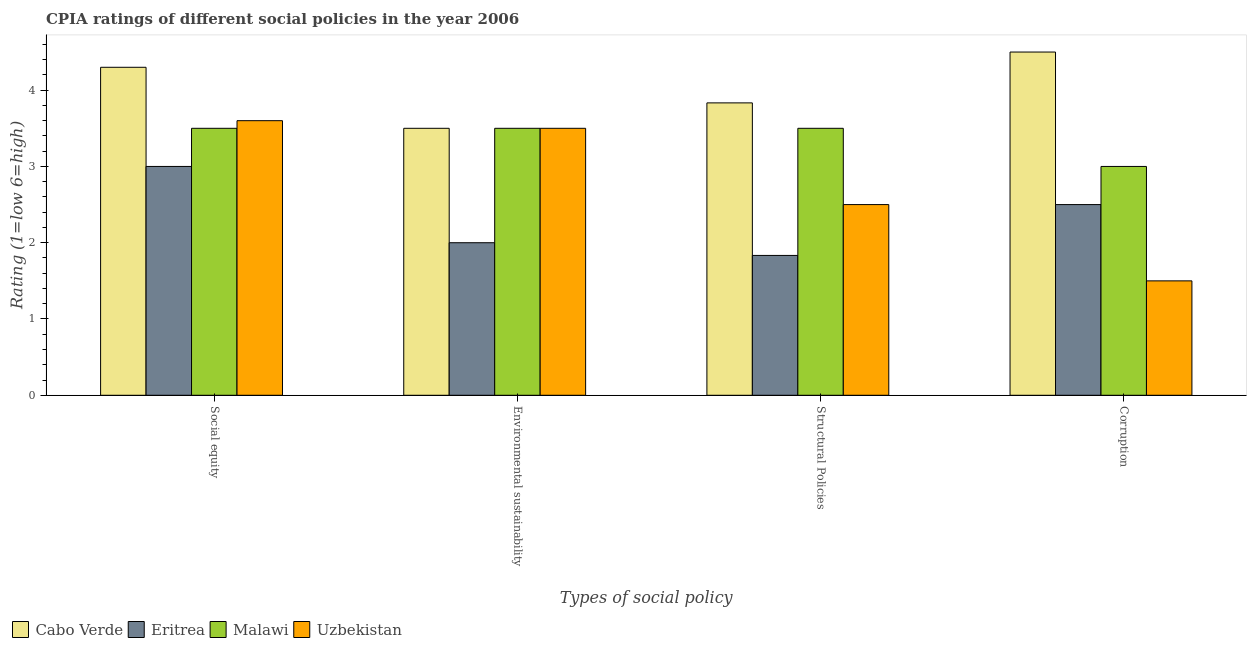Are the number of bars per tick equal to the number of legend labels?
Offer a terse response. Yes. Are the number of bars on each tick of the X-axis equal?
Keep it short and to the point. Yes. How many bars are there on the 2nd tick from the right?
Your answer should be very brief. 4. What is the label of the 3rd group of bars from the left?
Provide a succinct answer. Structural Policies. Across all countries, what is the maximum cpia rating of social equity?
Give a very brief answer. 4.3. In which country was the cpia rating of corruption maximum?
Give a very brief answer. Cabo Verde. In which country was the cpia rating of corruption minimum?
Provide a succinct answer. Uzbekistan. What is the total cpia rating of social equity in the graph?
Keep it short and to the point. 14.4. What is the average cpia rating of social equity per country?
Your answer should be very brief. 3.6. What is the difference between the cpia rating of structural policies and cpia rating of environmental sustainability in Cabo Verde?
Your response must be concise. 0.33. Is the difference between the cpia rating of environmental sustainability in Eritrea and Uzbekistan greater than the difference between the cpia rating of corruption in Eritrea and Uzbekistan?
Offer a terse response. No. What is the difference between the highest and the second highest cpia rating of structural policies?
Your answer should be compact. 0.33. What is the difference between the highest and the lowest cpia rating of corruption?
Keep it short and to the point. 3. In how many countries, is the cpia rating of social equity greater than the average cpia rating of social equity taken over all countries?
Your answer should be very brief. 1. Is the sum of the cpia rating of corruption in Uzbekistan and Cabo Verde greater than the maximum cpia rating of social equity across all countries?
Your answer should be compact. Yes. What does the 1st bar from the left in Corruption represents?
Offer a terse response. Cabo Verde. What does the 4th bar from the right in Environmental sustainability represents?
Your answer should be very brief. Cabo Verde. How many countries are there in the graph?
Ensure brevity in your answer.  4. What is the difference between two consecutive major ticks on the Y-axis?
Provide a short and direct response. 1. Are the values on the major ticks of Y-axis written in scientific E-notation?
Keep it short and to the point. No. Does the graph contain any zero values?
Provide a succinct answer. No. How many legend labels are there?
Make the answer very short. 4. How are the legend labels stacked?
Give a very brief answer. Horizontal. What is the title of the graph?
Your answer should be compact. CPIA ratings of different social policies in the year 2006. Does "Iran" appear as one of the legend labels in the graph?
Offer a very short reply. No. What is the label or title of the X-axis?
Make the answer very short. Types of social policy. What is the label or title of the Y-axis?
Give a very brief answer. Rating (1=low 6=high). What is the Rating (1=low 6=high) in Malawi in Social equity?
Your response must be concise. 3.5. What is the Rating (1=low 6=high) in Cabo Verde in Environmental sustainability?
Your answer should be very brief. 3.5. What is the Rating (1=low 6=high) of Malawi in Environmental sustainability?
Your response must be concise. 3.5. What is the Rating (1=low 6=high) in Uzbekistan in Environmental sustainability?
Provide a short and direct response. 3.5. What is the Rating (1=low 6=high) of Cabo Verde in Structural Policies?
Make the answer very short. 3.83. What is the Rating (1=low 6=high) of Eritrea in Structural Policies?
Provide a short and direct response. 1.83. What is the Rating (1=low 6=high) of Uzbekistan in Structural Policies?
Your answer should be compact. 2.5. What is the Rating (1=low 6=high) in Eritrea in Corruption?
Your answer should be very brief. 2.5. Across all Types of social policy, what is the maximum Rating (1=low 6=high) in Cabo Verde?
Offer a very short reply. 4.5. Across all Types of social policy, what is the maximum Rating (1=low 6=high) of Malawi?
Your response must be concise. 3.5. Across all Types of social policy, what is the minimum Rating (1=low 6=high) in Cabo Verde?
Give a very brief answer. 3.5. Across all Types of social policy, what is the minimum Rating (1=low 6=high) in Eritrea?
Your answer should be very brief. 1.83. What is the total Rating (1=low 6=high) of Cabo Verde in the graph?
Your response must be concise. 16.13. What is the total Rating (1=low 6=high) of Eritrea in the graph?
Make the answer very short. 9.33. What is the difference between the Rating (1=low 6=high) in Eritrea in Social equity and that in Environmental sustainability?
Give a very brief answer. 1. What is the difference between the Rating (1=low 6=high) of Uzbekistan in Social equity and that in Environmental sustainability?
Your response must be concise. 0.1. What is the difference between the Rating (1=low 6=high) of Cabo Verde in Social equity and that in Structural Policies?
Your response must be concise. 0.47. What is the difference between the Rating (1=low 6=high) in Eritrea in Social equity and that in Structural Policies?
Provide a succinct answer. 1.17. What is the difference between the Rating (1=low 6=high) in Malawi in Social equity and that in Structural Policies?
Ensure brevity in your answer.  0. What is the difference between the Rating (1=low 6=high) in Uzbekistan in Social equity and that in Structural Policies?
Provide a succinct answer. 1.1. What is the difference between the Rating (1=low 6=high) in Eritrea in Social equity and that in Corruption?
Give a very brief answer. 0.5. What is the difference between the Rating (1=low 6=high) in Uzbekistan in Social equity and that in Corruption?
Make the answer very short. 2.1. What is the difference between the Rating (1=low 6=high) of Cabo Verde in Environmental sustainability and that in Structural Policies?
Offer a terse response. -0.33. What is the difference between the Rating (1=low 6=high) in Malawi in Environmental sustainability and that in Structural Policies?
Keep it short and to the point. 0. What is the difference between the Rating (1=low 6=high) of Cabo Verde in Environmental sustainability and that in Corruption?
Your answer should be compact. -1. What is the difference between the Rating (1=low 6=high) in Eritrea in Environmental sustainability and that in Corruption?
Ensure brevity in your answer.  -0.5. What is the difference between the Rating (1=low 6=high) of Malawi in Environmental sustainability and that in Corruption?
Your answer should be compact. 0.5. What is the difference between the Rating (1=low 6=high) of Cabo Verde in Social equity and the Rating (1=low 6=high) of Malawi in Environmental sustainability?
Your answer should be very brief. 0.8. What is the difference between the Rating (1=low 6=high) in Cabo Verde in Social equity and the Rating (1=low 6=high) in Uzbekistan in Environmental sustainability?
Give a very brief answer. 0.8. What is the difference between the Rating (1=low 6=high) of Eritrea in Social equity and the Rating (1=low 6=high) of Malawi in Environmental sustainability?
Ensure brevity in your answer.  -0.5. What is the difference between the Rating (1=low 6=high) in Malawi in Social equity and the Rating (1=low 6=high) in Uzbekistan in Environmental sustainability?
Offer a very short reply. 0. What is the difference between the Rating (1=low 6=high) of Cabo Verde in Social equity and the Rating (1=low 6=high) of Eritrea in Structural Policies?
Keep it short and to the point. 2.47. What is the difference between the Rating (1=low 6=high) of Cabo Verde in Social equity and the Rating (1=low 6=high) of Malawi in Structural Policies?
Offer a very short reply. 0.8. What is the difference between the Rating (1=low 6=high) of Cabo Verde in Social equity and the Rating (1=low 6=high) of Uzbekistan in Structural Policies?
Keep it short and to the point. 1.8. What is the difference between the Rating (1=low 6=high) of Malawi in Social equity and the Rating (1=low 6=high) of Uzbekistan in Structural Policies?
Your response must be concise. 1. What is the difference between the Rating (1=low 6=high) in Cabo Verde in Social equity and the Rating (1=low 6=high) in Eritrea in Corruption?
Provide a succinct answer. 1.8. What is the difference between the Rating (1=low 6=high) in Cabo Verde in Social equity and the Rating (1=low 6=high) in Malawi in Corruption?
Offer a very short reply. 1.3. What is the difference between the Rating (1=low 6=high) in Cabo Verde in Social equity and the Rating (1=low 6=high) in Uzbekistan in Corruption?
Keep it short and to the point. 2.8. What is the difference between the Rating (1=low 6=high) of Eritrea in Social equity and the Rating (1=low 6=high) of Uzbekistan in Corruption?
Offer a very short reply. 1.5. What is the difference between the Rating (1=low 6=high) of Cabo Verde in Environmental sustainability and the Rating (1=low 6=high) of Eritrea in Structural Policies?
Make the answer very short. 1.67. What is the difference between the Rating (1=low 6=high) in Cabo Verde in Environmental sustainability and the Rating (1=low 6=high) in Uzbekistan in Structural Policies?
Offer a very short reply. 1. What is the difference between the Rating (1=low 6=high) of Eritrea in Environmental sustainability and the Rating (1=low 6=high) of Malawi in Structural Policies?
Make the answer very short. -1.5. What is the difference between the Rating (1=low 6=high) in Eritrea in Environmental sustainability and the Rating (1=low 6=high) in Uzbekistan in Structural Policies?
Offer a very short reply. -0.5. What is the difference between the Rating (1=low 6=high) in Malawi in Environmental sustainability and the Rating (1=low 6=high) in Uzbekistan in Structural Policies?
Your answer should be compact. 1. What is the difference between the Rating (1=low 6=high) in Cabo Verde in Environmental sustainability and the Rating (1=low 6=high) in Eritrea in Corruption?
Make the answer very short. 1. What is the difference between the Rating (1=low 6=high) in Cabo Verde in Environmental sustainability and the Rating (1=low 6=high) in Uzbekistan in Corruption?
Your answer should be compact. 2. What is the difference between the Rating (1=low 6=high) of Eritrea in Environmental sustainability and the Rating (1=low 6=high) of Uzbekistan in Corruption?
Your answer should be very brief. 0.5. What is the difference between the Rating (1=low 6=high) in Cabo Verde in Structural Policies and the Rating (1=low 6=high) in Eritrea in Corruption?
Offer a very short reply. 1.33. What is the difference between the Rating (1=low 6=high) in Cabo Verde in Structural Policies and the Rating (1=low 6=high) in Malawi in Corruption?
Ensure brevity in your answer.  0.83. What is the difference between the Rating (1=low 6=high) of Cabo Verde in Structural Policies and the Rating (1=low 6=high) of Uzbekistan in Corruption?
Provide a short and direct response. 2.33. What is the difference between the Rating (1=low 6=high) in Eritrea in Structural Policies and the Rating (1=low 6=high) in Malawi in Corruption?
Your answer should be compact. -1.17. What is the difference between the Rating (1=low 6=high) in Eritrea in Structural Policies and the Rating (1=low 6=high) in Uzbekistan in Corruption?
Provide a short and direct response. 0.33. What is the average Rating (1=low 6=high) in Cabo Verde per Types of social policy?
Your answer should be compact. 4.03. What is the average Rating (1=low 6=high) in Eritrea per Types of social policy?
Ensure brevity in your answer.  2.33. What is the average Rating (1=low 6=high) of Malawi per Types of social policy?
Your response must be concise. 3.38. What is the average Rating (1=low 6=high) of Uzbekistan per Types of social policy?
Your answer should be compact. 2.77. What is the difference between the Rating (1=low 6=high) in Cabo Verde and Rating (1=low 6=high) in Eritrea in Social equity?
Provide a short and direct response. 1.3. What is the difference between the Rating (1=low 6=high) in Cabo Verde and Rating (1=low 6=high) in Malawi in Social equity?
Your response must be concise. 0.8. What is the difference between the Rating (1=low 6=high) of Cabo Verde and Rating (1=low 6=high) of Uzbekistan in Social equity?
Your answer should be compact. 0.7. What is the difference between the Rating (1=low 6=high) of Eritrea and Rating (1=low 6=high) of Uzbekistan in Social equity?
Your answer should be compact. -0.6. What is the difference between the Rating (1=low 6=high) of Malawi and Rating (1=low 6=high) of Uzbekistan in Social equity?
Offer a very short reply. -0.1. What is the difference between the Rating (1=low 6=high) of Cabo Verde and Rating (1=low 6=high) of Uzbekistan in Environmental sustainability?
Provide a succinct answer. 0. What is the difference between the Rating (1=low 6=high) in Eritrea and Rating (1=low 6=high) in Malawi in Environmental sustainability?
Make the answer very short. -1.5. What is the difference between the Rating (1=low 6=high) in Eritrea and Rating (1=low 6=high) in Uzbekistan in Environmental sustainability?
Ensure brevity in your answer.  -1.5. What is the difference between the Rating (1=low 6=high) of Malawi and Rating (1=low 6=high) of Uzbekistan in Environmental sustainability?
Provide a succinct answer. 0. What is the difference between the Rating (1=low 6=high) of Cabo Verde and Rating (1=low 6=high) of Eritrea in Structural Policies?
Provide a short and direct response. 2. What is the difference between the Rating (1=low 6=high) in Cabo Verde and Rating (1=low 6=high) in Uzbekistan in Structural Policies?
Ensure brevity in your answer.  1.33. What is the difference between the Rating (1=low 6=high) of Eritrea and Rating (1=low 6=high) of Malawi in Structural Policies?
Give a very brief answer. -1.67. What is the difference between the Rating (1=low 6=high) of Eritrea and Rating (1=low 6=high) of Uzbekistan in Structural Policies?
Keep it short and to the point. -0.67. What is the difference between the Rating (1=low 6=high) of Malawi and Rating (1=low 6=high) of Uzbekistan in Structural Policies?
Give a very brief answer. 1. What is the difference between the Rating (1=low 6=high) in Cabo Verde and Rating (1=low 6=high) in Malawi in Corruption?
Your answer should be compact. 1.5. What is the difference between the Rating (1=low 6=high) in Cabo Verde and Rating (1=low 6=high) in Uzbekistan in Corruption?
Give a very brief answer. 3. What is the ratio of the Rating (1=low 6=high) of Cabo Verde in Social equity to that in Environmental sustainability?
Provide a succinct answer. 1.23. What is the ratio of the Rating (1=low 6=high) of Uzbekistan in Social equity to that in Environmental sustainability?
Offer a very short reply. 1.03. What is the ratio of the Rating (1=low 6=high) in Cabo Verde in Social equity to that in Structural Policies?
Provide a short and direct response. 1.12. What is the ratio of the Rating (1=low 6=high) of Eritrea in Social equity to that in Structural Policies?
Ensure brevity in your answer.  1.64. What is the ratio of the Rating (1=low 6=high) in Malawi in Social equity to that in Structural Policies?
Your response must be concise. 1. What is the ratio of the Rating (1=low 6=high) in Uzbekistan in Social equity to that in Structural Policies?
Your answer should be compact. 1.44. What is the ratio of the Rating (1=low 6=high) in Cabo Verde in Social equity to that in Corruption?
Provide a short and direct response. 0.96. What is the ratio of the Rating (1=low 6=high) in Cabo Verde in Environmental sustainability to that in Structural Policies?
Make the answer very short. 0.91. What is the ratio of the Rating (1=low 6=high) of Uzbekistan in Environmental sustainability to that in Structural Policies?
Offer a very short reply. 1.4. What is the ratio of the Rating (1=low 6=high) of Eritrea in Environmental sustainability to that in Corruption?
Offer a terse response. 0.8. What is the ratio of the Rating (1=low 6=high) of Uzbekistan in Environmental sustainability to that in Corruption?
Provide a succinct answer. 2.33. What is the ratio of the Rating (1=low 6=high) in Cabo Verde in Structural Policies to that in Corruption?
Offer a terse response. 0.85. What is the ratio of the Rating (1=low 6=high) in Eritrea in Structural Policies to that in Corruption?
Your answer should be compact. 0.73. What is the ratio of the Rating (1=low 6=high) of Malawi in Structural Policies to that in Corruption?
Offer a terse response. 1.17. What is the ratio of the Rating (1=low 6=high) of Uzbekistan in Structural Policies to that in Corruption?
Offer a very short reply. 1.67. What is the difference between the highest and the second highest Rating (1=low 6=high) of Malawi?
Provide a short and direct response. 0. What is the difference between the highest and the lowest Rating (1=low 6=high) in Cabo Verde?
Provide a short and direct response. 1. What is the difference between the highest and the lowest Rating (1=low 6=high) in Eritrea?
Offer a very short reply. 1.17. 